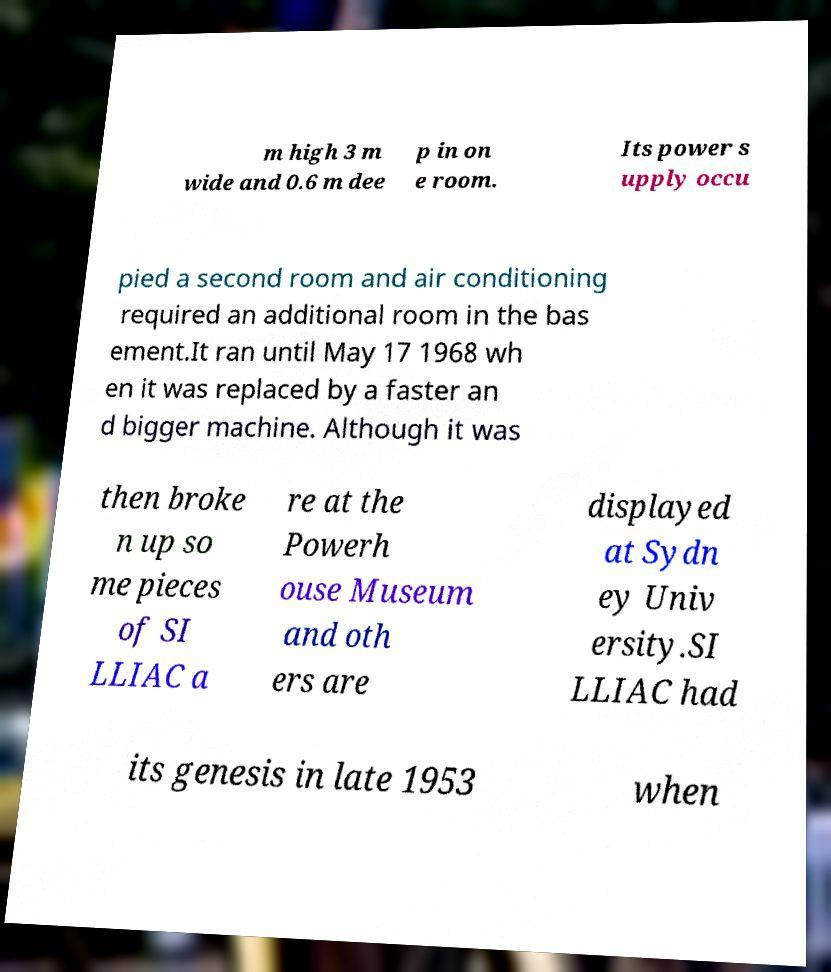There's text embedded in this image that I need extracted. Can you transcribe it verbatim? m high 3 m wide and 0.6 m dee p in on e room. Its power s upply occu pied a second room and air conditioning required an additional room in the bas ement.It ran until May 17 1968 wh en it was replaced by a faster an d bigger machine. Although it was then broke n up so me pieces of SI LLIAC a re at the Powerh ouse Museum and oth ers are displayed at Sydn ey Univ ersity.SI LLIAC had its genesis in late 1953 when 